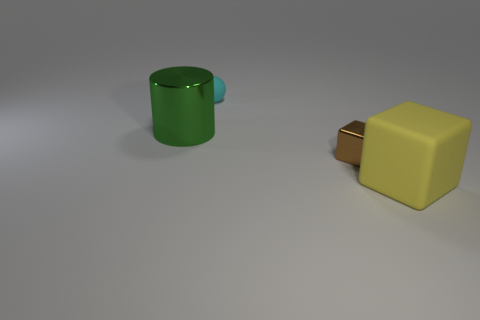Add 4 yellow rubber cubes. How many objects exist? 8 Add 1 green cylinders. How many green cylinders are left? 2 Add 1 tiny things. How many tiny things exist? 3 Subtract 0 gray spheres. How many objects are left? 4 Subtract all big cylinders. Subtract all matte spheres. How many objects are left? 2 